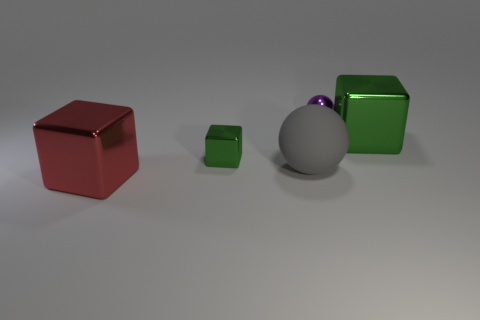Are there fewer large red objects that are right of the large rubber sphere than large green things behind the purple metallic thing?
Ensure brevity in your answer.  No. Is there a purple shiny thing of the same shape as the large red thing?
Provide a short and direct response. No. Do the small green metallic thing and the big gray thing have the same shape?
Offer a terse response. No. How many large things are either red matte blocks or purple spheres?
Make the answer very short. 0. Is the number of tiny gray metallic objects greater than the number of tiny metallic blocks?
Your response must be concise. No. There is a purple thing that is made of the same material as the small green block; what size is it?
Ensure brevity in your answer.  Small. Do the sphere behind the big gray matte sphere and the metal block on the right side of the small purple object have the same size?
Keep it short and to the point. No. What number of objects are either objects in front of the small metallic sphere or big blue blocks?
Your response must be concise. 4. Is the number of big shiny things less than the number of large spheres?
Offer a very short reply. No. There is a thing that is behind the big metal cube that is to the right of the thing that is in front of the large gray matte sphere; what shape is it?
Provide a short and direct response. Sphere. 